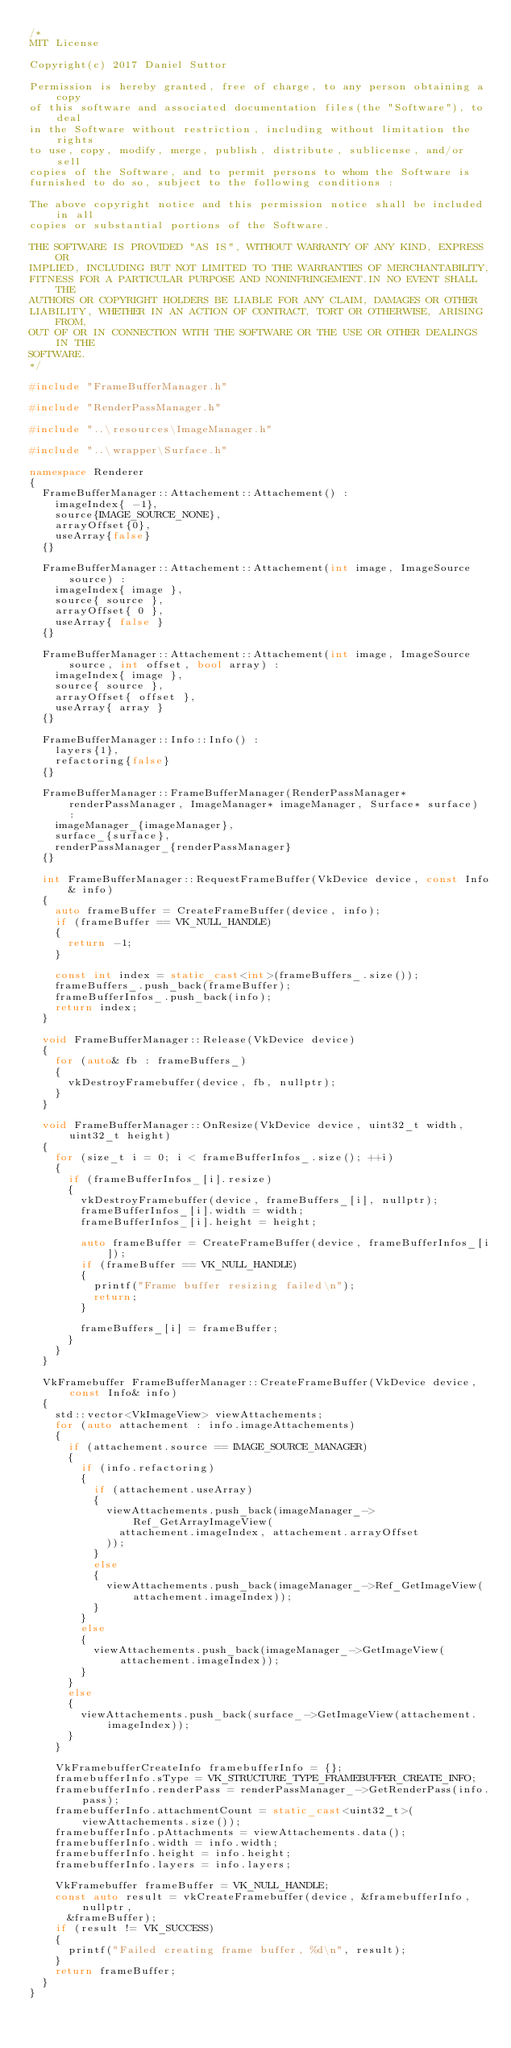<code> <loc_0><loc_0><loc_500><loc_500><_C++_>/*
MIT License

Copyright(c) 2017 Daniel Suttor

Permission is hereby granted, free of charge, to any person obtaining a copy
of this software and associated documentation files(the "Software"), to deal
in the Software without restriction, including without limitation the rights
to use, copy, modify, merge, publish, distribute, sublicense, and/or sell
copies of the Software, and to permit persons to whom the Software is
furnished to do so, subject to the following conditions :

The above copyright notice and this permission notice shall be included in all
copies or substantial portions of the Software.

THE SOFTWARE IS PROVIDED "AS IS", WITHOUT WARRANTY OF ANY KIND, EXPRESS OR
IMPLIED, INCLUDING BUT NOT LIMITED TO THE WARRANTIES OF MERCHANTABILITY,
FITNESS FOR A PARTICULAR PURPOSE AND NONINFRINGEMENT.IN NO EVENT SHALL THE
AUTHORS OR COPYRIGHT HOLDERS BE LIABLE FOR ANY CLAIM, DAMAGES OR OTHER
LIABILITY, WHETHER IN AN ACTION OF CONTRACT, TORT OR OTHERWISE, ARISING FROM,
OUT OF OR IN CONNECTION WITH THE SOFTWARE OR THE USE OR OTHER DEALINGS IN THE
SOFTWARE.
*/

#include "FrameBufferManager.h"

#include "RenderPassManager.h"

#include "..\resources\ImageManager.h"

#include "..\wrapper\Surface.h"

namespace Renderer
{
  FrameBufferManager::Attachement::Attachement() :
    imageIndex{ -1},
    source{IMAGE_SOURCE_NONE},
    arrayOffset{0},
    useArray{false}
  {}

  FrameBufferManager::Attachement::Attachement(int image, ImageSource source) :
    imageIndex{ image },
    source{ source },
    arrayOffset{ 0 },
    useArray{ false }
  {}

  FrameBufferManager::Attachement::Attachement(int image, ImageSource source, int offset, bool array) :
    imageIndex{ image },
    source{ source },
    arrayOffset{ offset },
    useArray{ array }
  {}

  FrameBufferManager::Info::Info() :
    layers{1},
    refactoring{false}
  {}

  FrameBufferManager::FrameBufferManager(RenderPassManager* renderPassManager, ImageManager* imageManager, Surface* surface) :
    imageManager_{imageManager},
    surface_{surface},
    renderPassManager_{renderPassManager}
  {}

  int FrameBufferManager::RequestFrameBuffer(VkDevice device, const Info& info)
  {
    auto frameBuffer = CreateFrameBuffer(device, info);
    if (frameBuffer == VK_NULL_HANDLE)
    {
      return -1;
    }

    const int index = static_cast<int>(frameBuffers_.size());
    frameBuffers_.push_back(frameBuffer);
    frameBufferInfos_.push_back(info);
    return index;
  }

  void FrameBufferManager::Release(VkDevice device)
  {
    for (auto& fb : frameBuffers_)
    {
      vkDestroyFramebuffer(device, fb, nullptr);
    }
  }

  void FrameBufferManager::OnResize(VkDevice device, uint32_t width, uint32_t height)
  {
    for (size_t i = 0; i < frameBufferInfos_.size(); ++i)
    {
      if (frameBufferInfos_[i].resize)
      {
        vkDestroyFramebuffer(device, frameBuffers_[i], nullptr);
        frameBufferInfos_[i].width = width;
        frameBufferInfos_[i].height = height;

        auto frameBuffer = CreateFrameBuffer(device, frameBufferInfos_[i]);
        if (frameBuffer == VK_NULL_HANDLE)
        {
          printf("Frame buffer resizing failed\n");
          return;
        }

        frameBuffers_[i] = frameBuffer;
      }
    }
  }

  VkFramebuffer FrameBufferManager::CreateFrameBuffer(VkDevice device, const Info& info)
  {
    std::vector<VkImageView> viewAttachements;
    for (auto attachement : info.imageAttachements)
    {
      if (attachement.source == IMAGE_SOURCE_MANAGER)
      {
        if (info.refactoring)
        {
          if (attachement.useArray)
          {
            viewAttachements.push_back(imageManager_->Ref_GetArrayImageView(
              attachement.imageIndex, attachement.arrayOffset
            ));
          }
          else
          {
            viewAttachements.push_back(imageManager_->Ref_GetImageView(attachement.imageIndex));
          }
        }
        else
        {
          viewAttachements.push_back(imageManager_->GetImageView(attachement.imageIndex));
        }
      }
      else
      {
        viewAttachements.push_back(surface_->GetImageView(attachement.imageIndex));
      }
    }

    VkFramebufferCreateInfo framebufferInfo = {};
    framebufferInfo.sType = VK_STRUCTURE_TYPE_FRAMEBUFFER_CREATE_INFO;
    framebufferInfo.renderPass = renderPassManager_->GetRenderPass(info.pass);
    framebufferInfo.attachmentCount = static_cast<uint32_t>(viewAttachements.size());
    framebufferInfo.pAttachments = viewAttachements.data();
    framebufferInfo.width = info.width;
    framebufferInfo.height = info.height;
    framebufferInfo.layers = info.layers;

    VkFramebuffer frameBuffer = VK_NULL_HANDLE;
    const auto result = vkCreateFramebuffer(device, &framebufferInfo, nullptr,
      &frameBuffer);
    if (result != VK_SUCCESS)
    {
      printf("Failed creating frame buffer, %d\n", result);
    }
    return frameBuffer;
  }
}</code> 